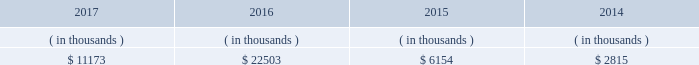Is expected to begin by late-2018 , after the necessary information technology infrastructure is in place .
Entergy louisiana proposed to recover the cost of ami through the implementation of a customer charge , net of certain benefits , phased in over the period 2019 through 2022 .
The parties reached an uncontested stipulation permitting implementation of entergy louisiana 2019s proposed ami system , with modifications to the proposed customer charge .
In july 2017 the lpsc approved the stipulation .
Entergy louisiana expects to recover the undepreciated balance of its existing meters through a regulatory asset at current depreciation rates .
Sources of capital entergy louisiana 2019s sources to meet its capital requirements include : 2022 internally generated funds ; 2022 cash on hand ; 2022 debt or preferred membership interest issuances ; and 2022 bank financing under new or existing facilities .
Entergy louisiana may refinance , redeem , or otherwise retire debt prior to maturity , to the extent market conditions and interest rates are favorable .
All debt and common and preferred membership interest issuances by entergy louisiana require prior regulatory approval .
Preferred membership interest and debt issuances are also subject to issuance tests set forth in its bond indentures and other agreements .
Entergy louisiana has sufficient capacity under these tests to meet its foreseeable capital needs .
Entergy louisiana 2019s receivables from the money pool were as follows as of december 31 for each of the following years. .
See note 4 to the financial statements for a description of the money pool .
Entergy louisiana has a credit facility in the amount of $ 350 million scheduled to expire in august 2022 .
The credit facility allows entergy louisiana to issue letters of credit against $ 15 million of the borrowing capacity of the facility .
As of december 31 , 2017 , there were no cash borrowings and a $ 9.1 million letter of credit outstanding under the credit facility .
In addition , entergy louisiana is a party to an uncommitted letter of credit facility as a means to post collateral to support its obligations to miso . a0 as of december 31 , 2017 , a $ 29.7 million letter of credit was outstanding under entergy louisiana 2019s uncommitted letter of credit a0facility .
See note 4 to the financial statements for additional discussion of the credit facilities .
The entergy louisiana nuclear fuel company variable interest entities have two separate credit facilities , one in the amount of $ 105 million and one in the amount of $ 85 million , both scheduled to expire in may 2019 .
As of december 31 , 2017 , $ 65.7 million of loans were outstanding under the credit facility for the entergy louisiana river bend nuclear fuel company variable interest entity .
As of december 31 , 2017 , $ 43.5 million in letters of credit to support a like amount of commercial paper issued and $ 36.4 million in loans were outstanding under the entergy louisiana waterford nuclear fuel company variable interest entity credit facility .
See note 4 to the financial statements for additional discussion of the nuclear fuel company variable interest entity credit facilities .
Entergy louisiana , llc and subsidiaries management 2019s financial discussion and analysis .
What was the percent of the entergy louisiana letters of credit against authorized to be issued against the borrowing capacity of the facility? 
Computations: (15 / 350)
Answer: 0.04286. 